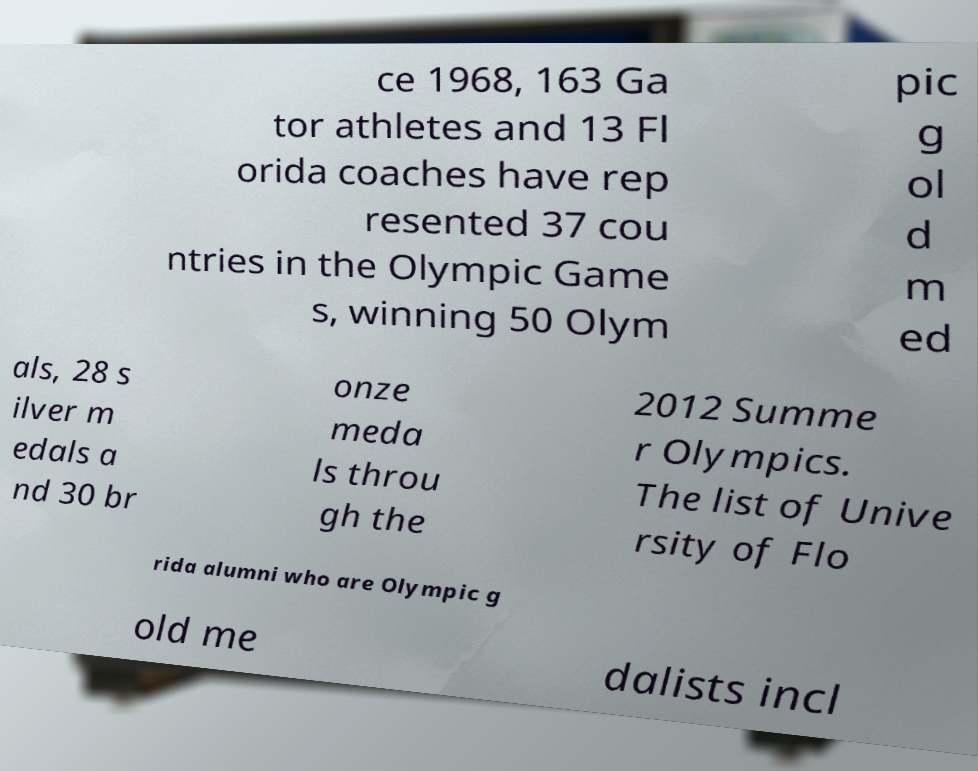Can you read and provide the text displayed in the image?This photo seems to have some interesting text. Can you extract and type it out for me? ce 1968, 163 Ga tor athletes and 13 Fl orida coaches have rep resented 37 cou ntries in the Olympic Game s, winning 50 Olym pic g ol d m ed als, 28 s ilver m edals a nd 30 br onze meda ls throu gh the 2012 Summe r Olympics. The list of Unive rsity of Flo rida alumni who are Olympic g old me dalists incl 